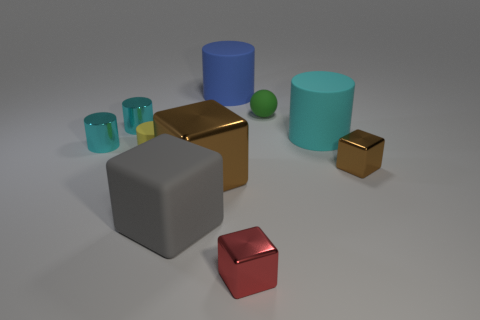How many small yellow shiny things are there?
Give a very brief answer. 0. How many big objects are either blue things or brown objects?
Provide a succinct answer. 2. The brown thing that is the same size as the red block is what shape?
Provide a short and direct response. Cube. The cyan cylinder right of the brown cube that is left of the small red cube is made of what material?
Give a very brief answer. Rubber. Is the size of the cyan matte object the same as the blue rubber cylinder?
Offer a very short reply. Yes. What number of objects are either cyan objects that are right of the yellow thing or shiny objects?
Provide a short and direct response. 6. There is a small thing that is in front of the brown metal cube that is right of the red shiny object; what is its shape?
Give a very brief answer. Cube. There is a red cube; is it the same size as the cyan thing that is to the right of the yellow thing?
Make the answer very short. No. There is a brown object in front of the tiny brown block; what material is it?
Offer a terse response. Metal. How many objects are both to the right of the tiny yellow rubber object and on the left side of the tiny brown shiny block?
Provide a succinct answer. 6. 